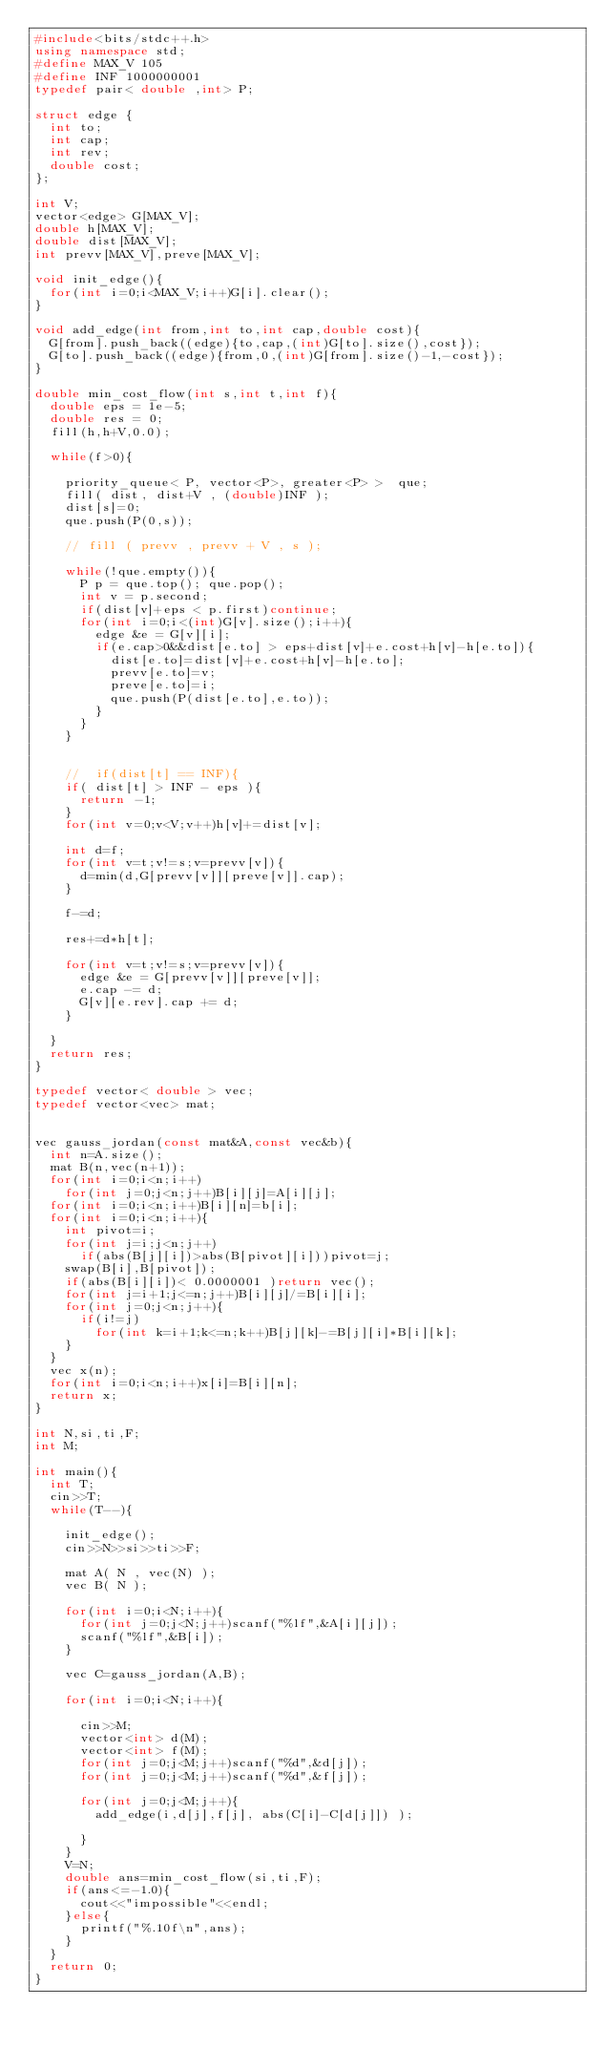<code> <loc_0><loc_0><loc_500><loc_500><_C++_>#include<bits/stdc++.h>
using namespace std;
#define MAX_V 105
#define INF 1000000001
typedef pair< double ,int> P;

struct edge {
  int to;
  int cap;
  int rev;
  double cost;
};

int V;
vector<edge> G[MAX_V];
double h[MAX_V];
double dist[MAX_V];
int prevv[MAX_V],preve[MAX_V];

void init_edge(){
  for(int i=0;i<MAX_V;i++)G[i].clear();
}

void add_edge(int from,int to,int cap,double cost){
  G[from].push_back((edge){to,cap,(int)G[to].size(),cost});
  G[to].push_back((edge){from,0,(int)G[from].size()-1,-cost});
}

double min_cost_flow(int s,int t,int f){
  double eps = 1e-5;
  double res = 0;
  fill(h,h+V,0.0);
  
  while(f>0){
    
    priority_queue< P, vector<P>, greater<P> >  que;
    fill( dist, dist+V , (double)INF );
    dist[s]=0;
    que.push(P(0,s));

    // fill ( prevv , prevv + V , s );
    
    while(!que.empty()){
      P p = que.top(); que.pop();
      int v = p.second;
      if(dist[v]+eps < p.first)continue;
      for(int i=0;i<(int)G[v].size();i++){
        edge &e = G[v][i];
        if(e.cap>0&&dist[e.to] > eps+dist[v]+e.cost+h[v]-h[e.to]){
          dist[e.to]=dist[v]+e.cost+h[v]-h[e.to];
          prevv[e.to]=v;
          preve[e.to]=i;
          que.push(P(dist[e.to],e.to));
        }
      }
    }

        
    //  if(dist[t] == INF){
    if( dist[t] > INF - eps ){
      return -1;
    }
    for(int v=0;v<V;v++)h[v]+=dist[v]; 

    int d=f;
    for(int v=t;v!=s;v=prevv[v]){
      d=min(d,G[prevv[v]][preve[v]].cap);
    }
  
    f-=d;

    res+=d*h[t];

    for(int v=t;v!=s;v=prevv[v]){
      edge &e = G[prevv[v]][preve[v]];
      e.cap -= d;
      G[v][e.rev].cap += d;
    }

  }
  return res;
}

typedef vector< double > vec;
typedef vector<vec> mat;


vec gauss_jordan(const mat&A,const vec&b){
  int n=A.size();
  mat B(n,vec(n+1));
  for(int i=0;i<n;i++)
    for(int j=0;j<n;j++)B[i][j]=A[i][j];
  for(int i=0;i<n;i++)B[i][n]=b[i];
  for(int i=0;i<n;i++){
    int pivot=i;
    for(int j=i;j<n;j++)
      if(abs(B[j][i])>abs(B[pivot][i]))pivot=j;
    swap(B[i],B[pivot]);
    if(abs(B[i][i])< 0.0000001 )return vec();
    for(int j=i+1;j<=n;j++)B[i][j]/=B[i][i];
    for(int j=0;j<n;j++){
      if(i!=j)
        for(int k=i+1;k<=n;k++)B[j][k]-=B[j][i]*B[i][k];
    }
  }
  vec x(n);
  for(int i=0;i<n;i++)x[i]=B[i][n];
  return x;
}

int N,si,ti,F;
int M;

int main(){
  int T;
  cin>>T;
  while(T--){

    init_edge();
    cin>>N>>si>>ti>>F;
    
    mat A( N , vec(N) );
    vec B( N );
    
    for(int i=0;i<N;i++){
      for(int j=0;j<N;j++)scanf("%lf",&A[i][j]);
      scanf("%lf",&B[i]);
    }
    
    vec C=gauss_jordan(A,B);
    
    for(int i=0;i<N;i++){
      
      cin>>M;
      vector<int> d(M);
      vector<int> f(M);
      for(int j=0;j<M;j++)scanf("%d",&d[j]);
      for(int j=0;j<M;j++)scanf("%d",&f[j]);
      
      for(int j=0;j<M;j++){
        add_edge(i,d[j],f[j], abs(C[i]-C[d[j]]) );
        
      }
    }
    V=N;
    double ans=min_cost_flow(si,ti,F);
    if(ans<=-1.0){
      cout<<"impossible"<<endl;
    }else{
      printf("%.10f\n",ans);
    }
  }
  return 0;
}</code> 